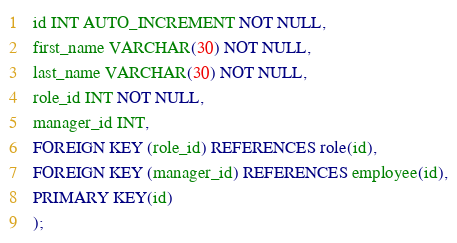Convert code to text. <code><loc_0><loc_0><loc_500><loc_500><_SQL_>  id INT AUTO_INCREMENT NOT NULL,
  first_name VARCHAR(30) NOT NULL,
  last_name VARCHAR(30) NOT NULL,
  role_id INT NOT NULL,
  manager_id INT,
  FOREIGN KEY (role_id) REFERENCES role(id),
  FOREIGN KEY (manager_id) REFERENCES employee(id),
  PRIMARY KEY(id)
  );</code> 